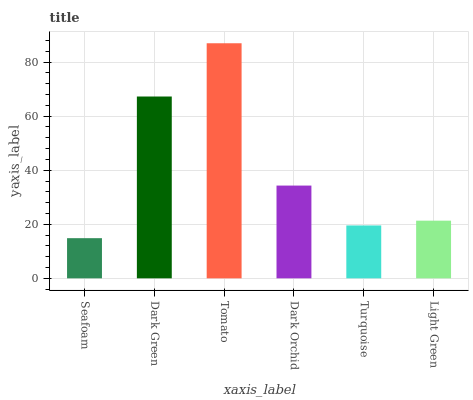Is Dark Green the minimum?
Answer yes or no. No. Is Dark Green the maximum?
Answer yes or no. No. Is Dark Green greater than Seafoam?
Answer yes or no. Yes. Is Seafoam less than Dark Green?
Answer yes or no. Yes. Is Seafoam greater than Dark Green?
Answer yes or no. No. Is Dark Green less than Seafoam?
Answer yes or no. No. Is Dark Orchid the high median?
Answer yes or no. Yes. Is Light Green the low median?
Answer yes or no. Yes. Is Seafoam the high median?
Answer yes or no. No. Is Dark Orchid the low median?
Answer yes or no. No. 